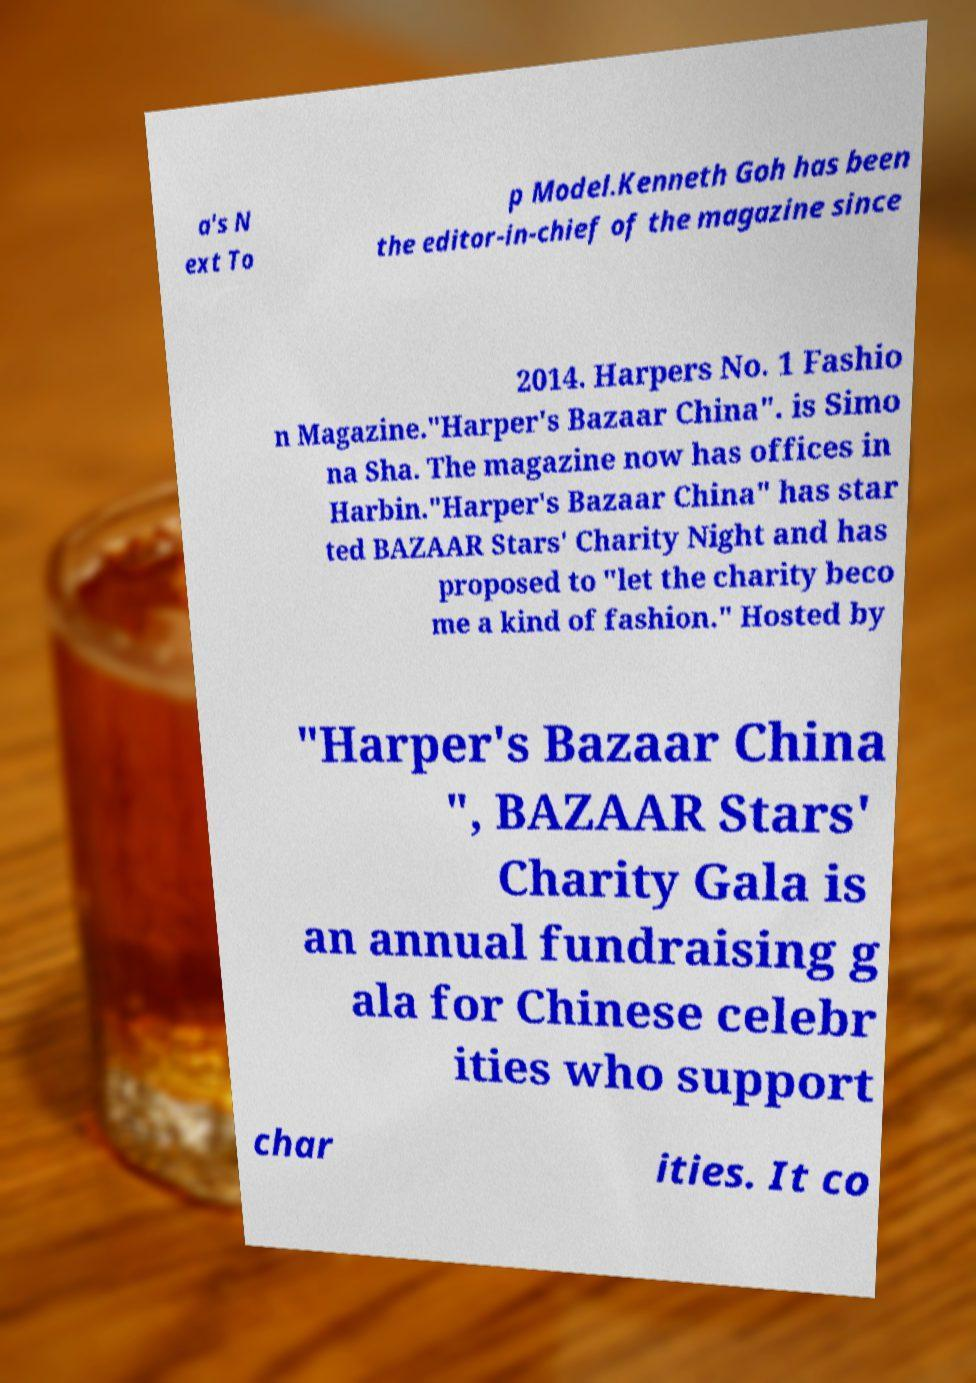For documentation purposes, I need the text within this image transcribed. Could you provide that? a's N ext To p Model.Kenneth Goh has been the editor-in-chief of the magazine since 2014. Harpers No. 1 Fashio n Magazine."Harper's Bazaar China". is Simo na Sha. The magazine now has offices in Harbin."Harper's Bazaar China" has star ted BAZAAR Stars' Charity Night and has proposed to "let the charity beco me a kind of fashion." Hosted by "Harper's Bazaar China ", BAZAAR Stars' Charity Gala is an annual fundraising g ala for Chinese celebr ities who support char ities. It co 